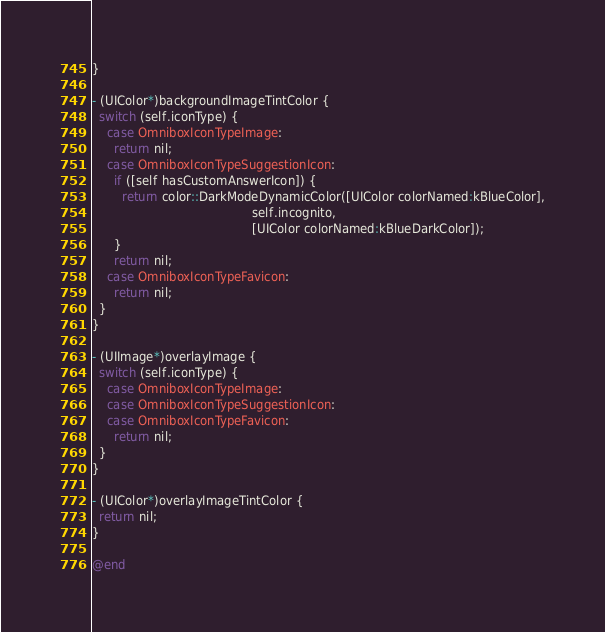<code> <loc_0><loc_0><loc_500><loc_500><_ObjectiveC_>}

- (UIColor*)backgroundImageTintColor {
  switch (self.iconType) {
    case OmniboxIconTypeImage:
      return nil;
    case OmniboxIconTypeSuggestionIcon:
      if ([self hasCustomAnswerIcon]) {
        return color::DarkModeDynamicColor([UIColor colorNamed:kBlueColor],
                                           self.incognito,
                                           [UIColor colorNamed:kBlueDarkColor]);
      }
      return nil;
    case OmniboxIconTypeFavicon:
      return nil;
  }
}

- (UIImage*)overlayImage {
  switch (self.iconType) {
    case OmniboxIconTypeImage:
    case OmniboxIconTypeSuggestionIcon:
    case OmniboxIconTypeFavicon:
      return nil;
  }
}

- (UIColor*)overlayImageTintColor {
  return nil;
}

@end
</code> 